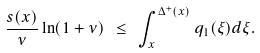Convert formula to latex. <formula><loc_0><loc_0><loc_500><loc_500>\frac { s ( x ) } { \nu } \ln ( 1 + \nu ) \ \leq \ \int _ { x } ^ { \Delta ^ { + } ( x ) } q _ { 1 } ( \xi ) d \xi .</formula> 